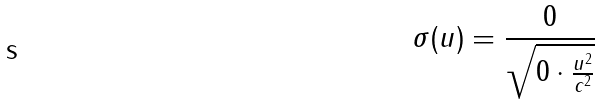<formula> <loc_0><loc_0><loc_500><loc_500>\sigma ( u ) = \frac { 0 } { \sqrt { 0 \cdot \frac { u ^ { 2 } } { c ^ { 2 } } } }</formula> 